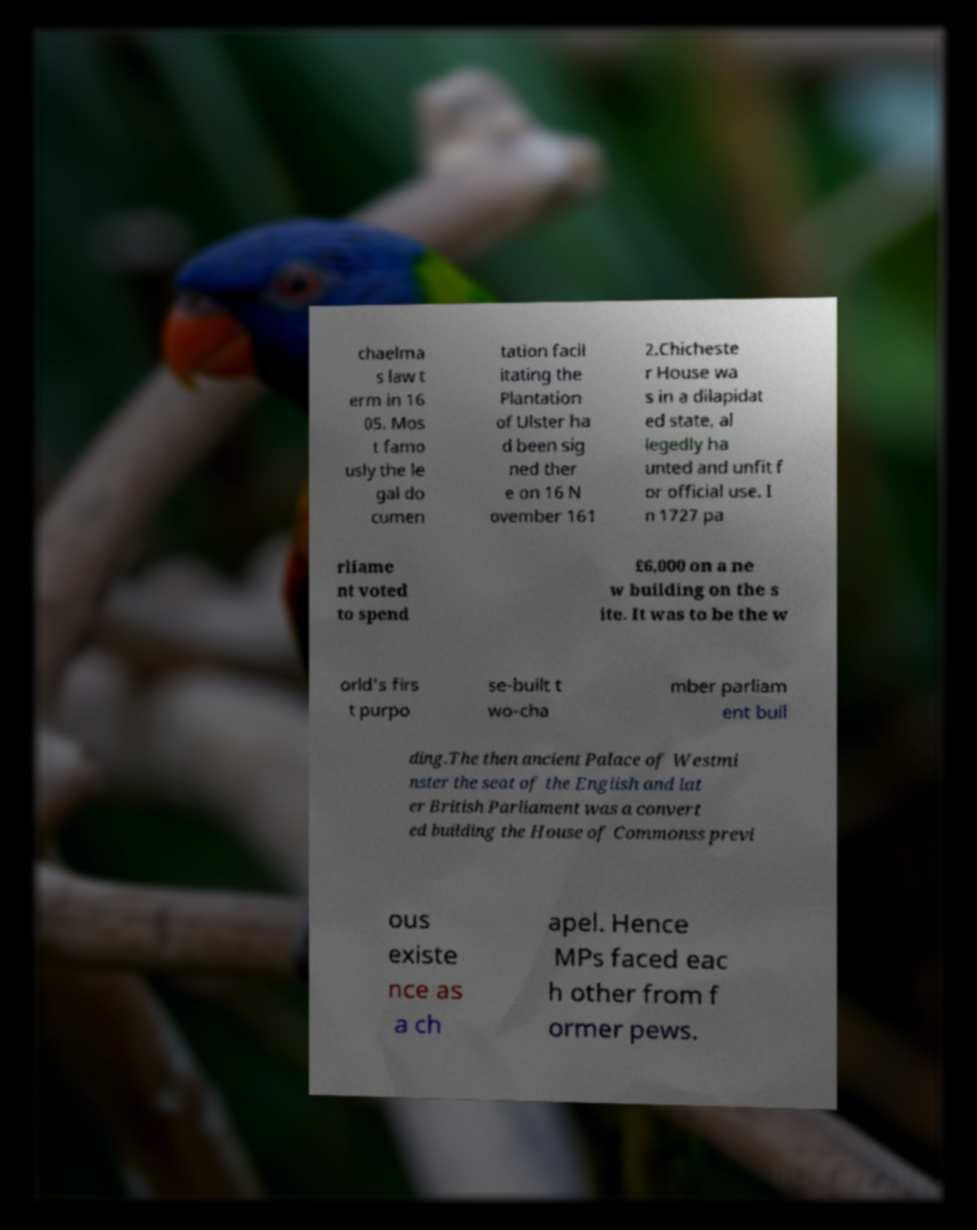Please identify and transcribe the text found in this image. chaelma s law t erm in 16 05. Mos t famo usly the le gal do cumen tation facil itating the Plantation of Ulster ha d been sig ned ther e on 16 N ovember 161 2.Chicheste r House wa s in a dilapidat ed state, al legedly ha unted and unfit f or official use. I n 1727 pa rliame nt voted to spend £6,000 on a ne w building on the s ite. It was to be the w orld's firs t purpo se-built t wo-cha mber parliam ent buil ding.The then ancient Palace of Westmi nster the seat of the English and lat er British Parliament was a convert ed building the House of Commonss previ ous existe nce as a ch apel. Hence MPs faced eac h other from f ormer pews. 